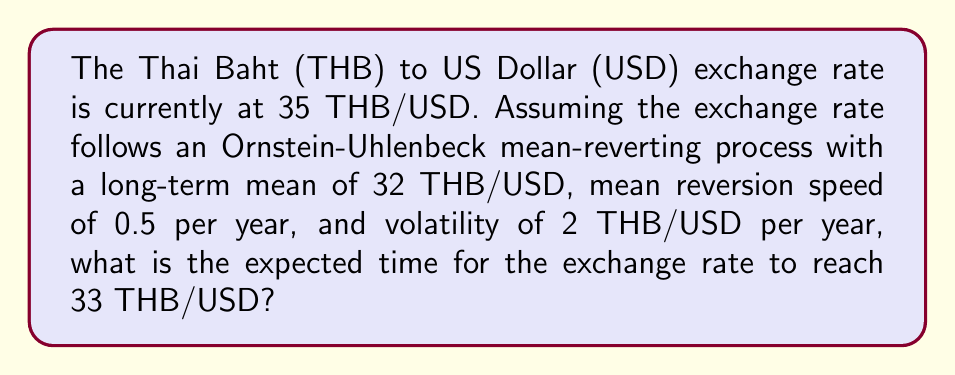What is the answer to this math problem? To solve this problem, we'll use the properties of the Ornstein-Uhlenbeck process:

1) First, recall the formula for the expected time to reach a specific level in a mean-reverting process:

   $$E[T] = -\frac{2}{\lambda} \ln\left(\frac{|x_T - \mu|}{|x_0 - \mu|}\right)$$

   Where:
   $E[T]$ is the expected time
   $\lambda$ is the mean reversion speed
   $x_T$ is the target level
   $\mu$ is the long-term mean
   $x_0$ is the initial level

2) Given:
   $\lambda = 0.5$ per year
   $x_T = 33$ THB/USD
   $\mu = 32$ THB/USD
   $x_0 = 35$ THB/USD

3) Substituting these values into the formula:

   $$E[T] = -\frac{2}{0.5} \ln\left(\frac{|33 - 32|}{|35 - 32|}\right)$$

4) Simplify:
   $$E[T] = -4 \ln\left(\frac{1}{3}\right)$$

5) Calculate:
   $$E[T] = -4 \times (-1.0986) = 4.3944$$

Therefore, the expected time for the THB/USD exchange rate to reach 33 THB/USD is approximately 4.39 years.
Answer: 4.39 years 